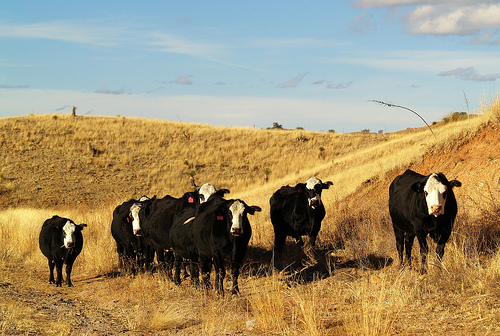<image>
Is the cows on the road? Yes. Looking at the image, I can see the cows is positioned on top of the road, with the road providing support. 